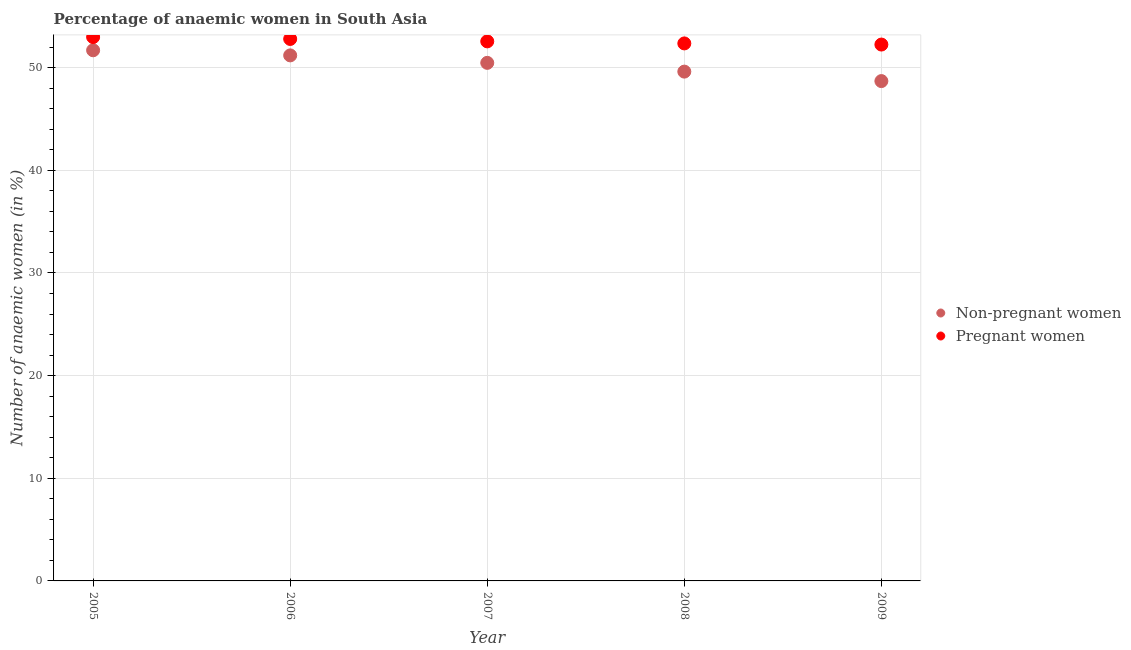Is the number of dotlines equal to the number of legend labels?
Offer a terse response. Yes. What is the percentage of pregnant anaemic women in 2008?
Ensure brevity in your answer.  52.36. Across all years, what is the maximum percentage of non-pregnant anaemic women?
Your answer should be very brief. 51.69. Across all years, what is the minimum percentage of non-pregnant anaemic women?
Offer a very short reply. 48.69. In which year was the percentage of pregnant anaemic women minimum?
Give a very brief answer. 2009. What is the total percentage of non-pregnant anaemic women in the graph?
Offer a terse response. 251.66. What is the difference between the percentage of non-pregnant anaemic women in 2006 and that in 2007?
Give a very brief answer. 0.73. What is the difference between the percentage of pregnant anaemic women in 2006 and the percentage of non-pregnant anaemic women in 2008?
Make the answer very short. 3.18. What is the average percentage of non-pregnant anaemic women per year?
Your answer should be compact. 50.33. In the year 2005, what is the difference between the percentage of non-pregnant anaemic women and percentage of pregnant anaemic women?
Provide a succinct answer. -1.29. What is the ratio of the percentage of pregnant anaemic women in 2006 to that in 2007?
Your answer should be very brief. 1. Is the percentage of pregnant anaemic women in 2005 less than that in 2008?
Your response must be concise. No. What is the difference between the highest and the second highest percentage of non-pregnant anaemic women?
Make the answer very short. 0.5. What is the difference between the highest and the lowest percentage of non-pregnant anaemic women?
Make the answer very short. 3. In how many years, is the percentage of non-pregnant anaemic women greater than the average percentage of non-pregnant anaemic women taken over all years?
Your answer should be compact. 3. Is the sum of the percentage of pregnant anaemic women in 2007 and 2008 greater than the maximum percentage of non-pregnant anaemic women across all years?
Your answer should be very brief. Yes. Does the percentage of pregnant anaemic women monotonically increase over the years?
Your answer should be very brief. No. Is the percentage of non-pregnant anaemic women strictly greater than the percentage of pregnant anaemic women over the years?
Keep it short and to the point. No. Is the percentage of non-pregnant anaemic women strictly less than the percentage of pregnant anaemic women over the years?
Your answer should be compact. Yes. How many dotlines are there?
Your answer should be compact. 2. What is the difference between two consecutive major ticks on the Y-axis?
Offer a very short reply. 10. Are the values on the major ticks of Y-axis written in scientific E-notation?
Ensure brevity in your answer.  No. Does the graph contain any zero values?
Your response must be concise. No. How are the legend labels stacked?
Make the answer very short. Vertical. What is the title of the graph?
Your response must be concise. Percentage of anaemic women in South Asia. What is the label or title of the Y-axis?
Offer a very short reply. Number of anaemic women (in %). What is the Number of anaemic women (in %) of Non-pregnant women in 2005?
Keep it short and to the point. 51.69. What is the Number of anaemic women (in %) of Pregnant women in 2005?
Ensure brevity in your answer.  52.98. What is the Number of anaemic women (in %) in Non-pregnant women in 2006?
Offer a terse response. 51.19. What is the Number of anaemic women (in %) in Pregnant women in 2006?
Your answer should be compact. 52.8. What is the Number of anaemic women (in %) in Non-pregnant women in 2007?
Your response must be concise. 50.47. What is the Number of anaemic women (in %) in Pregnant women in 2007?
Provide a short and direct response. 52.56. What is the Number of anaemic women (in %) of Non-pregnant women in 2008?
Ensure brevity in your answer.  49.61. What is the Number of anaemic women (in %) in Pregnant women in 2008?
Make the answer very short. 52.36. What is the Number of anaemic women (in %) in Non-pregnant women in 2009?
Your answer should be very brief. 48.69. What is the Number of anaemic women (in %) of Pregnant women in 2009?
Ensure brevity in your answer.  52.25. Across all years, what is the maximum Number of anaemic women (in %) of Non-pregnant women?
Your response must be concise. 51.69. Across all years, what is the maximum Number of anaemic women (in %) of Pregnant women?
Give a very brief answer. 52.98. Across all years, what is the minimum Number of anaemic women (in %) of Non-pregnant women?
Make the answer very short. 48.69. Across all years, what is the minimum Number of anaemic women (in %) in Pregnant women?
Your response must be concise. 52.25. What is the total Number of anaemic women (in %) of Non-pregnant women in the graph?
Keep it short and to the point. 251.66. What is the total Number of anaemic women (in %) of Pregnant women in the graph?
Your answer should be compact. 262.94. What is the difference between the Number of anaemic women (in %) of Non-pregnant women in 2005 and that in 2006?
Provide a short and direct response. 0.5. What is the difference between the Number of anaemic women (in %) of Pregnant women in 2005 and that in 2006?
Your answer should be compact. 0.18. What is the difference between the Number of anaemic women (in %) in Non-pregnant women in 2005 and that in 2007?
Your answer should be very brief. 1.23. What is the difference between the Number of anaemic women (in %) in Pregnant women in 2005 and that in 2007?
Give a very brief answer. 0.42. What is the difference between the Number of anaemic women (in %) of Non-pregnant women in 2005 and that in 2008?
Keep it short and to the point. 2.08. What is the difference between the Number of anaemic women (in %) in Pregnant women in 2005 and that in 2008?
Give a very brief answer. 0.62. What is the difference between the Number of anaemic women (in %) in Non-pregnant women in 2005 and that in 2009?
Your response must be concise. 3. What is the difference between the Number of anaemic women (in %) of Pregnant women in 2005 and that in 2009?
Provide a short and direct response. 0.73. What is the difference between the Number of anaemic women (in %) of Non-pregnant women in 2006 and that in 2007?
Your answer should be very brief. 0.73. What is the difference between the Number of anaemic women (in %) of Pregnant women in 2006 and that in 2007?
Ensure brevity in your answer.  0.23. What is the difference between the Number of anaemic women (in %) of Non-pregnant women in 2006 and that in 2008?
Your answer should be compact. 1.58. What is the difference between the Number of anaemic women (in %) of Pregnant women in 2006 and that in 2008?
Offer a terse response. 0.43. What is the difference between the Number of anaemic women (in %) of Non-pregnant women in 2006 and that in 2009?
Your answer should be very brief. 2.5. What is the difference between the Number of anaemic women (in %) in Pregnant women in 2006 and that in 2009?
Ensure brevity in your answer.  0.55. What is the difference between the Number of anaemic women (in %) of Non-pregnant women in 2007 and that in 2008?
Your answer should be very brief. 0.85. What is the difference between the Number of anaemic women (in %) in Pregnant women in 2007 and that in 2008?
Make the answer very short. 0.2. What is the difference between the Number of anaemic women (in %) in Non-pregnant women in 2007 and that in 2009?
Offer a terse response. 1.78. What is the difference between the Number of anaemic women (in %) of Pregnant women in 2007 and that in 2009?
Offer a terse response. 0.31. What is the difference between the Number of anaemic women (in %) of Non-pregnant women in 2008 and that in 2009?
Provide a short and direct response. 0.92. What is the difference between the Number of anaemic women (in %) of Pregnant women in 2008 and that in 2009?
Your answer should be compact. 0.11. What is the difference between the Number of anaemic women (in %) of Non-pregnant women in 2005 and the Number of anaemic women (in %) of Pregnant women in 2006?
Ensure brevity in your answer.  -1.1. What is the difference between the Number of anaemic women (in %) of Non-pregnant women in 2005 and the Number of anaemic women (in %) of Pregnant women in 2007?
Your answer should be compact. -0.87. What is the difference between the Number of anaemic women (in %) of Non-pregnant women in 2005 and the Number of anaemic women (in %) of Pregnant women in 2008?
Offer a terse response. -0.67. What is the difference between the Number of anaemic women (in %) of Non-pregnant women in 2005 and the Number of anaemic women (in %) of Pregnant women in 2009?
Your response must be concise. -0.56. What is the difference between the Number of anaemic women (in %) in Non-pregnant women in 2006 and the Number of anaemic women (in %) in Pregnant women in 2007?
Give a very brief answer. -1.37. What is the difference between the Number of anaemic women (in %) of Non-pregnant women in 2006 and the Number of anaemic women (in %) of Pregnant women in 2008?
Provide a succinct answer. -1.17. What is the difference between the Number of anaemic women (in %) in Non-pregnant women in 2006 and the Number of anaemic women (in %) in Pregnant women in 2009?
Your answer should be compact. -1.06. What is the difference between the Number of anaemic women (in %) of Non-pregnant women in 2007 and the Number of anaemic women (in %) of Pregnant women in 2008?
Give a very brief answer. -1.89. What is the difference between the Number of anaemic women (in %) of Non-pregnant women in 2007 and the Number of anaemic women (in %) of Pregnant women in 2009?
Make the answer very short. -1.78. What is the difference between the Number of anaemic women (in %) of Non-pregnant women in 2008 and the Number of anaemic women (in %) of Pregnant women in 2009?
Provide a succinct answer. -2.64. What is the average Number of anaemic women (in %) of Non-pregnant women per year?
Provide a succinct answer. 50.33. What is the average Number of anaemic women (in %) of Pregnant women per year?
Offer a very short reply. 52.59. In the year 2005, what is the difference between the Number of anaemic women (in %) in Non-pregnant women and Number of anaemic women (in %) in Pregnant women?
Your response must be concise. -1.29. In the year 2006, what is the difference between the Number of anaemic women (in %) of Non-pregnant women and Number of anaemic women (in %) of Pregnant women?
Offer a terse response. -1.6. In the year 2007, what is the difference between the Number of anaemic women (in %) of Non-pregnant women and Number of anaemic women (in %) of Pregnant women?
Your response must be concise. -2.09. In the year 2008, what is the difference between the Number of anaemic women (in %) of Non-pregnant women and Number of anaemic women (in %) of Pregnant women?
Provide a short and direct response. -2.75. In the year 2009, what is the difference between the Number of anaemic women (in %) of Non-pregnant women and Number of anaemic women (in %) of Pregnant women?
Your answer should be very brief. -3.56. What is the ratio of the Number of anaemic women (in %) of Non-pregnant women in 2005 to that in 2006?
Provide a short and direct response. 1.01. What is the ratio of the Number of anaemic women (in %) in Non-pregnant women in 2005 to that in 2007?
Give a very brief answer. 1.02. What is the ratio of the Number of anaemic women (in %) in Pregnant women in 2005 to that in 2007?
Your response must be concise. 1.01. What is the ratio of the Number of anaemic women (in %) of Non-pregnant women in 2005 to that in 2008?
Provide a short and direct response. 1.04. What is the ratio of the Number of anaemic women (in %) of Pregnant women in 2005 to that in 2008?
Give a very brief answer. 1.01. What is the ratio of the Number of anaemic women (in %) of Non-pregnant women in 2005 to that in 2009?
Your answer should be very brief. 1.06. What is the ratio of the Number of anaemic women (in %) of Pregnant women in 2005 to that in 2009?
Offer a terse response. 1.01. What is the ratio of the Number of anaemic women (in %) of Non-pregnant women in 2006 to that in 2007?
Offer a very short reply. 1.01. What is the ratio of the Number of anaemic women (in %) of Non-pregnant women in 2006 to that in 2008?
Provide a succinct answer. 1.03. What is the ratio of the Number of anaemic women (in %) of Pregnant women in 2006 to that in 2008?
Give a very brief answer. 1.01. What is the ratio of the Number of anaemic women (in %) of Non-pregnant women in 2006 to that in 2009?
Give a very brief answer. 1.05. What is the ratio of the Number of anaemic women (in %) in Pregnant women in 2006 to that in 2009?
Give a very brief answer. 1.01. What is the ratio of the Number of anaemic women (in %) of Non-pregnant women in 2007 to that in 2008?
Offer a terse response. 1.02. What is the ratio of the Number of anaemic women (in %) of Non-pregnant women in 2007 to that in 2009?
Provide a short and direct response. 1.04. What is the ratio of the Number of anaemic women (in %) of Pregnant women in 2007 to that in 2009?
Ensure brevity in your answer.  1.01. What is the ratio of the Number of anaemic women (in %) of Pregnant women in 2008 to that in 2009?
Offer a very short reply. 1. What is the difference between the highest and the second highest Number of anaemic women (in %) in Non-pregnant women?
Keep it short and to the point. 0.5. What is the difference between the highest and the second highest Number of anaemic women (in %) in Pregnant women?
Offer a terse response. 0.18. What is the difference between the highest and the lowest Number of anaemic women (in %) of Non-pregnant women?
Your answer should be very brief. 3. What is the difference between the highest and the lowest Number of anaemic women (in %) in Pregnant women?
Ensure brevity in your answer.  0.73. 